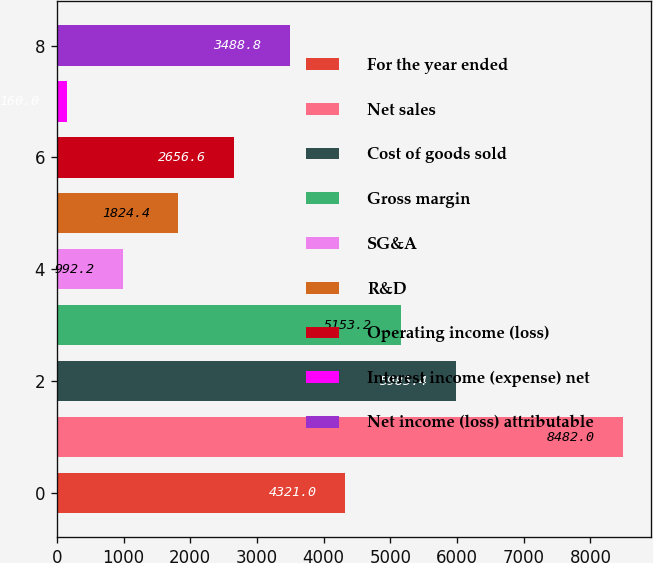<chart> <loc_0><loc_0><loc_500><loc_500><bar_chart><fcel>For the year ended<fcel>Net sales<fcel>Cost of goods sold<fcel>Gross margin<fcel>SG&A<fcel>R&D<fcel>Operating income (loss)<fcel>Interest income (expense) net<fcel>Net income (loss) attributable<nl><fcel>4321<fcel>8482<fcel>5985.4<fcel>5153.2<fcel>992.2<fcel>1824.4<fcel>2656.6<fcel>160<fcel>3488.8<nl></chart> 